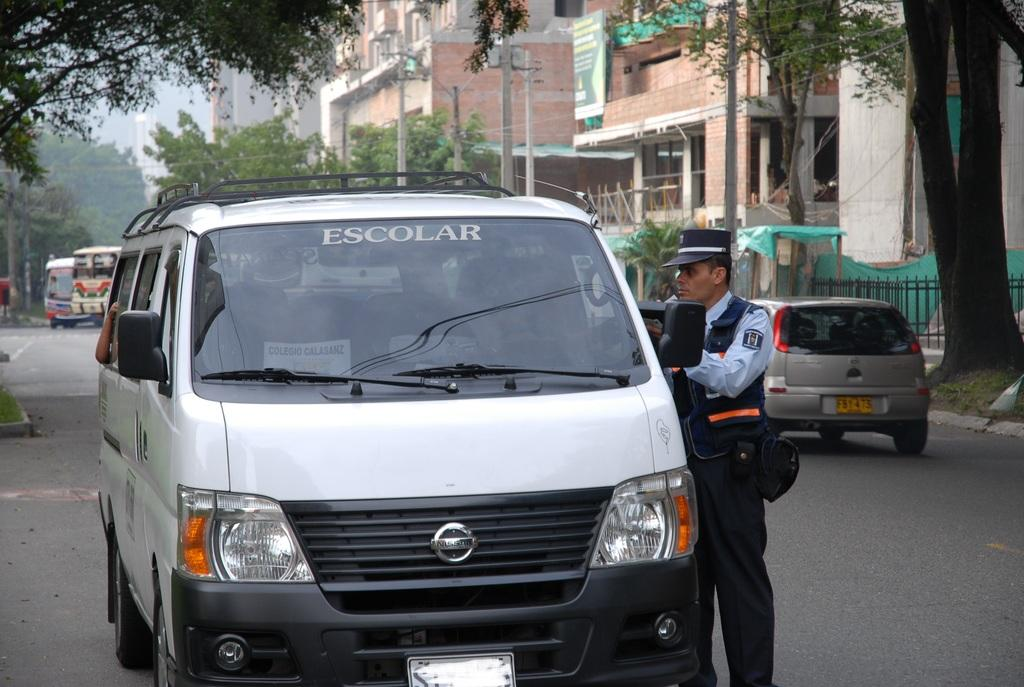What is the main feature of the image? There is a road in the image. What is happening on the road? There are vehicles on the road. Can you describe the person in the image? There is a man in uniform in the image. Where is the man in uniform located? The man in uniform is standing next to a vehicle. What can be seen in the background of the image? There are trees and buildings in the background of the image. What type of umbrella is the giant holding in the image? There are no giants or umbrellas present in the image. 